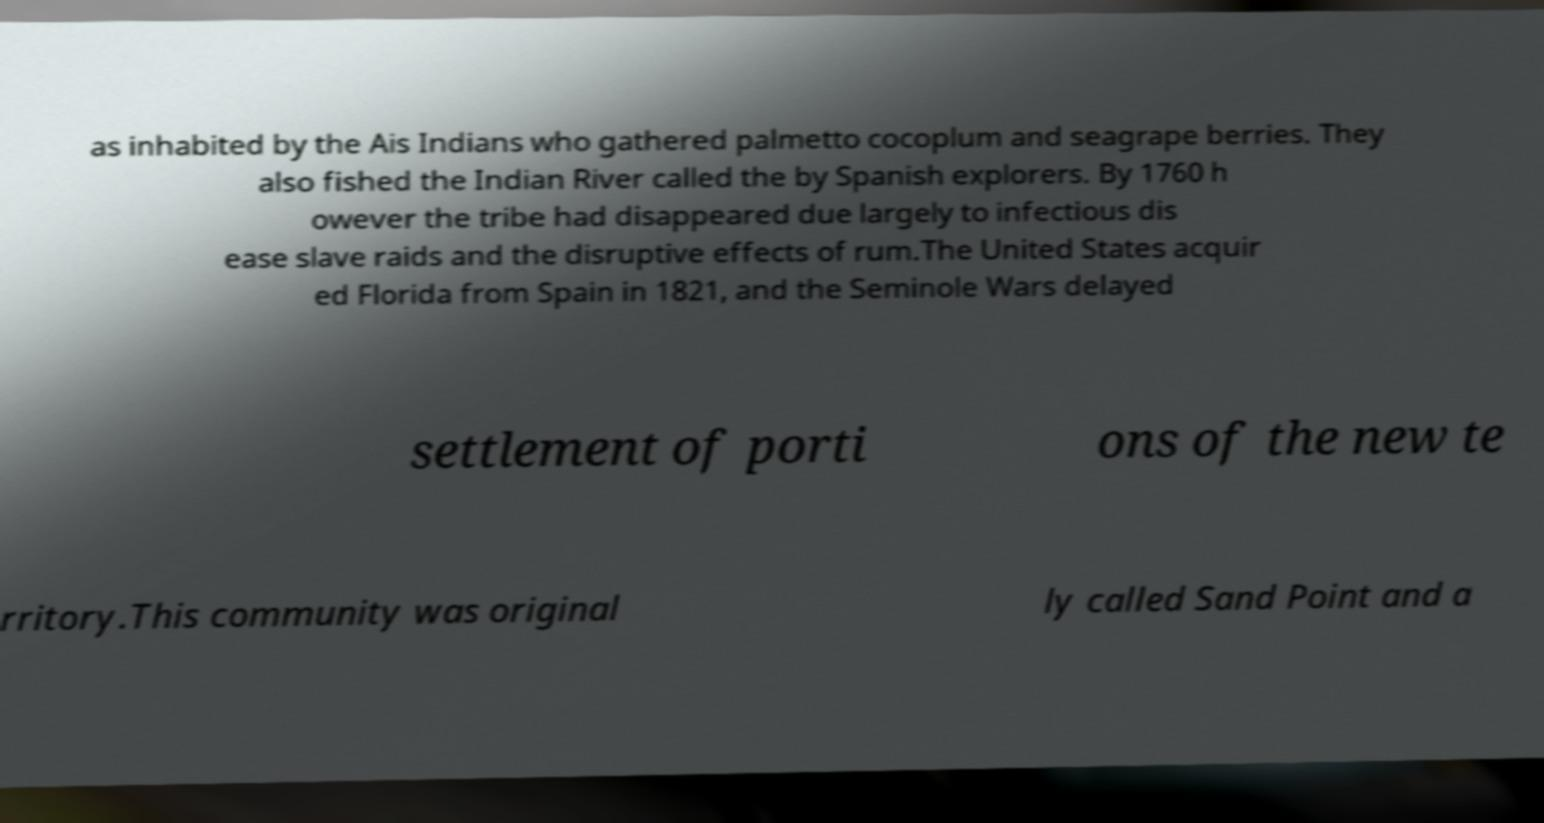I need the written content from this picture converted into text. Can you do that? as inhabited by the Ais Indians who gathered palmetto cocoplum and seagrape berries. They also fished the Indian River called the by Spanish explorers. By 1760 h owever the tribe had disappeared due largely to infectious dis ease slave raids and the disruptive effects of rum.The United States acquir ed Florida from Spain in 1821, and the Seminole Wars delayed settlement of porti ons of the new te rritory.This community was original ly called Sand Point and a 